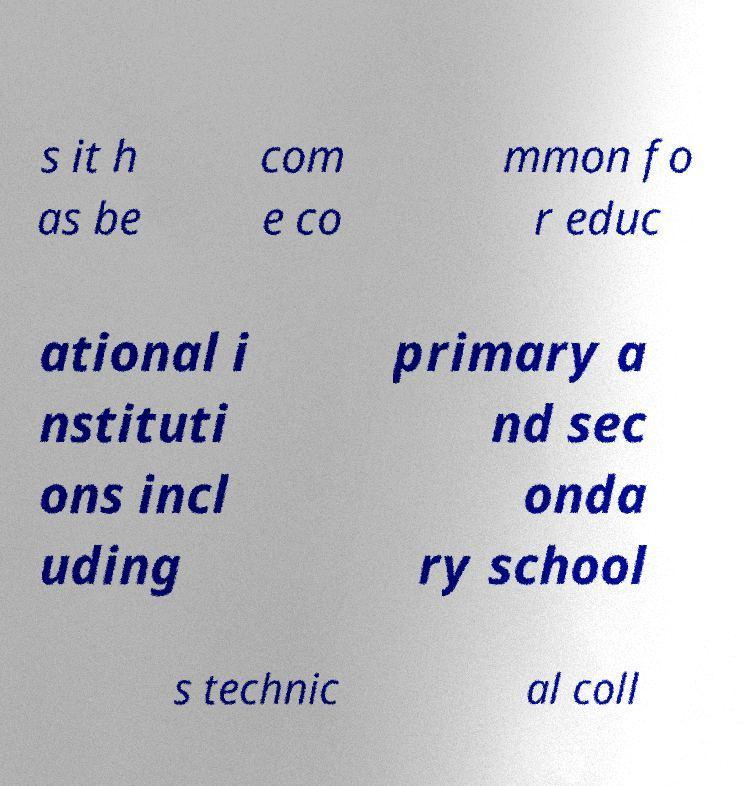For documentation purposes, I need the text within this image transcribed. Could you provide that? s it h as be com e co mmon fo r educ ational i nstituti ons incl uding primary a nd sec onda ry school s technic al coll 